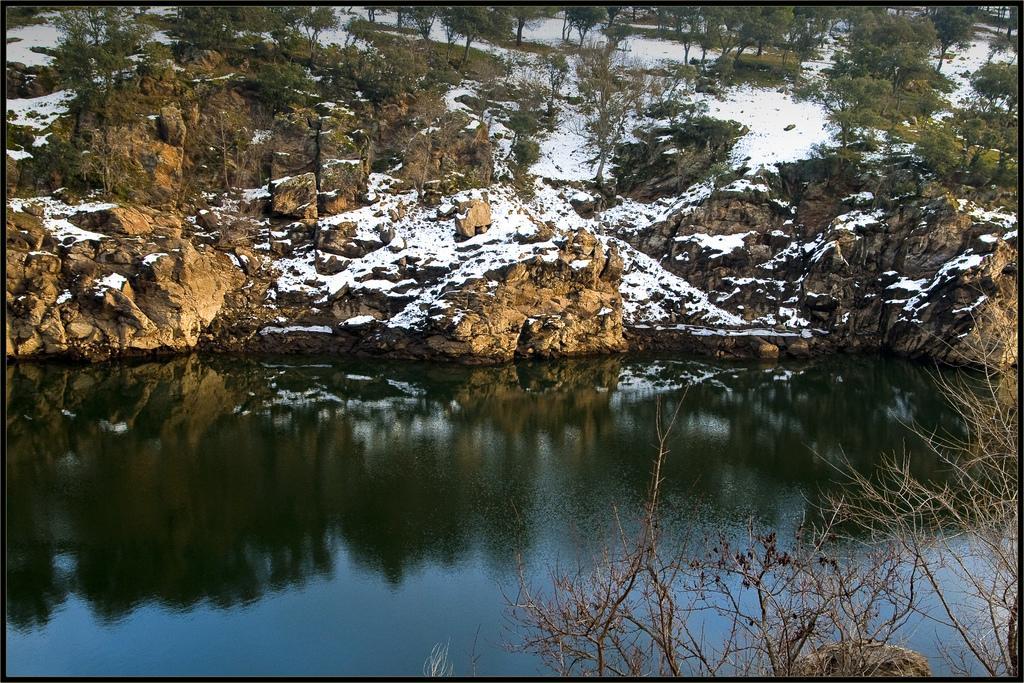How would you summarize this image in a sentence or two? In this image I can see the water. To the side of the water there are many rocks and trees. On the rocks I can see the snow. 